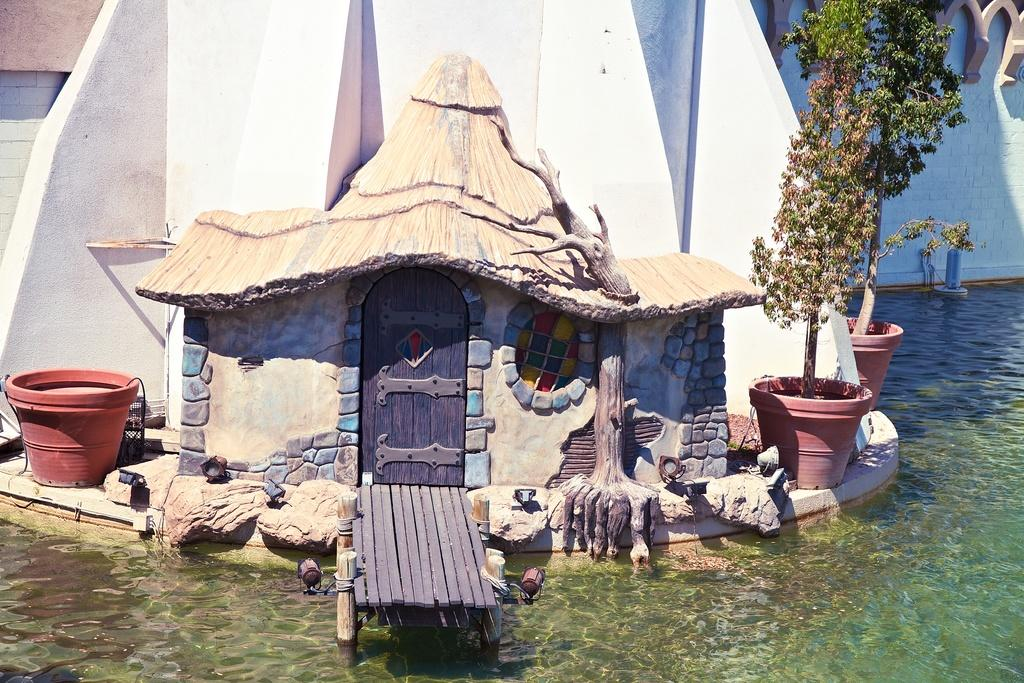What is the main subject in the center of the image? There is a model of a hut in the center of the image. What else can be seen in the image besides the hut? There are pots with plants and water visible in the image. What is located in the background on the right side? There is a wall in the background on the right side. How many minutes does it take for the screw to be visible in the image? There is no screw present in the image, so it cannot be determined how many minutes it would take for it to be visible. 